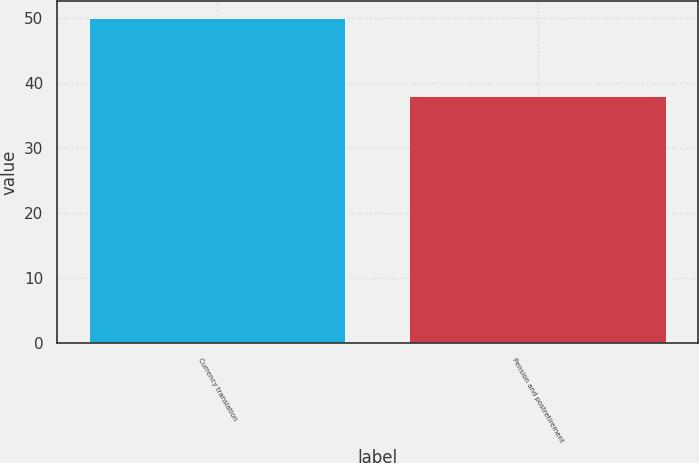<chart> <loc_0><loc_0><loc_500><loc_500><bar_chart><fcel>Currency translation<fcel>Pension and postretirement<nl><fcel>50<fcel>38<nl></chart> 